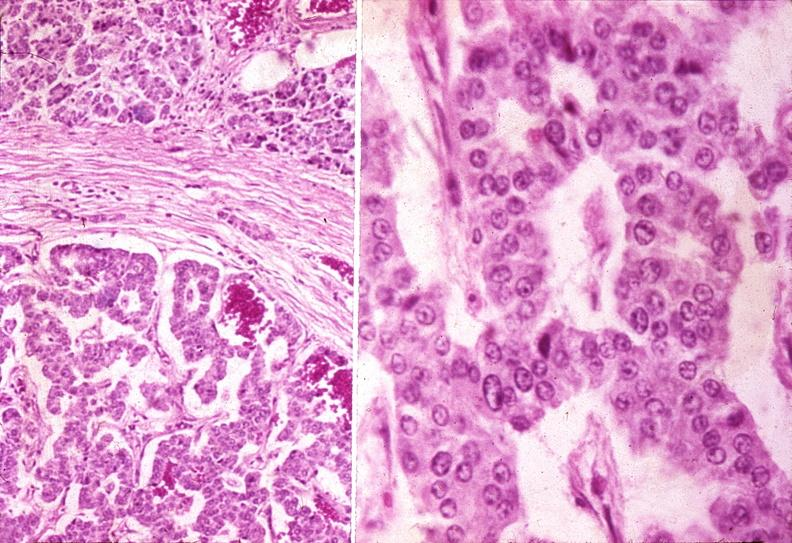what is present?
Answer the question using a single word or phrase. Pancreas 